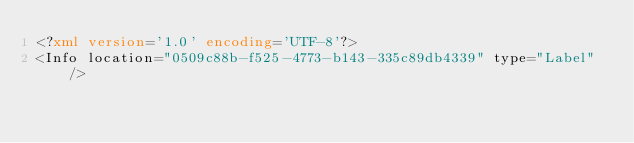Convert code to text. <code><loc_0><loc_0><loc_500><loc_500><_XML_><?xml version='1.0' encoding='UTF-8'?>
<Info location="0509c88b-f525-4773-b143-335c89db4339" type="Label" /></code> 